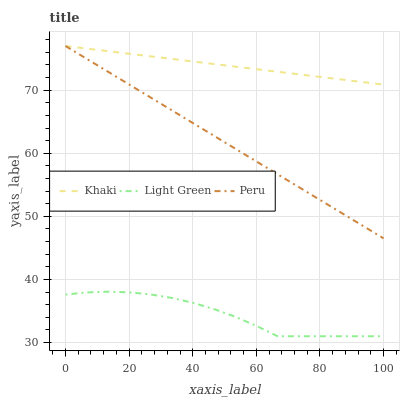Does Light Green have the minimum area under the curve?
Answer yes or no. Yes. Does Khaki have the maximum area under the curve?
Answer yes or no. Yes. Does Peru have the minimum area under the curve?
Answer yes or no. No. Does Peru have the maximum area under the curve?
Answer yes or no. No. Is Khaki the smoothest?
Answer yes or no. Yes. Is Light Green the roughest?
Answer yes or no. Yes. Is Peru the smoothest?
Answer yes or no. No. Is Peru the roughest?
Answer yes or no. No. Does Light Green have the lowest value?
Answer yes or no. Yes. Does Peru have the lowest value?
Answer yes or no. No. Does Peru have the highest value?
Answer yes or no. Yes. Does Light Green have the highest value?
Answer yes or no. No. Is Light Green less than Khaki?
Answer yes or no. Yes. Is Khaki greater than Light Green?
Answer yes or no. Yes. Does Khaki intersect Peru?
Answer yes or no. Yes. Is Khaki less than Peru?
Answer yes or no. No. Is Khaki greater than Peru?
Answer yes or no. No. Does Light Green intersect Khaki?
Answer yes or no. No. 